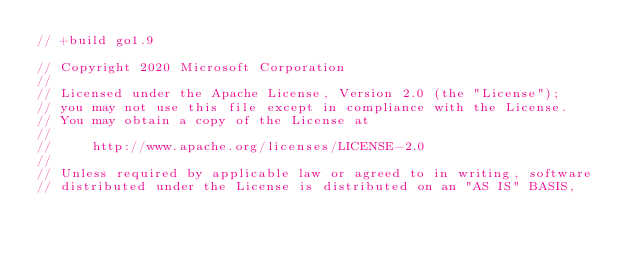Convert code to text. <code><loc_0><loc_0><loc_500><loc_500><_Go_>// +build go1.9

// Copyright 2020 Microsoft Corporation
//
// Licensed under the Apache License, Version 2.0 (the "License");
// you may not use this file except in compliance with the License.
// You may obtain a copy of the License at
//
//     http://www.apache.org/licenses/LICENSE-2.0
//
// Unless required by applicable law or agreed to in writing, software
// distributed under the License is distributed on an "AS IS" BASIS,</code> 